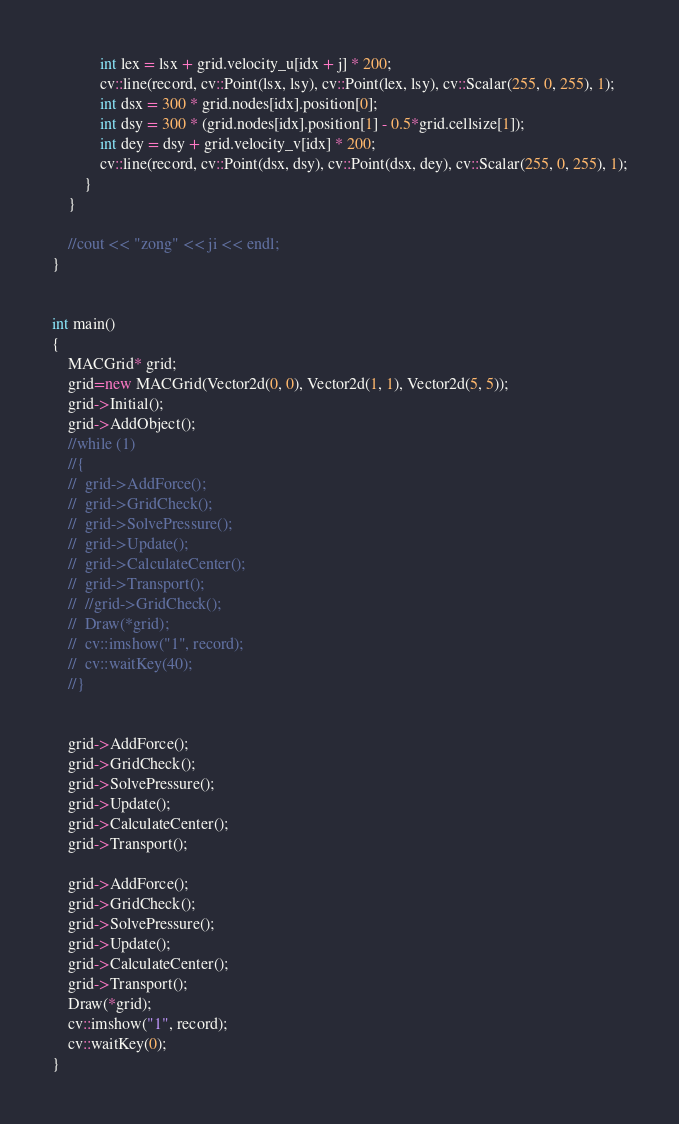Convert code to text. <code><loc_0><loc_0><loc_500><loc_500><_C++_>			int lex = lsx + grid.velocity_u[idx + j] * 200;
			cv::line(record, cv::Point(lsx, lsy), cv::Point(lex, lsy), cv::Scalar(255, 0, 255), 1);
			int dsx = 300 * grid.nodes[idx].position[0];
			int dsy = 300 * (grid.nodes[idx].position[1] - 0.5*grid.cellsize[1]);
			int dey = dsy + grid.velocity_v[idx] * 200;
			cv::line(record, cv::Point(dsx, dsy), cv::Point(dsx, dey), cv::Scalar(255, 0, 255), 1);
		}
	}

	//cout << "zong" << ji << endl;
}


int main()
{
	MACGrid* grid;
	grid=new MACGrid(Vector2d(0, 0), Vector2d(1, 1), Vector2d(5, 5));
	grid->Initial();
	grid->AddObject();
	//while (1)
	//{
	//	grid->AddForce();
	//	grid->GridCheck();
	//	grid->SolvePressure();
	//	grid->Update();
	//	grid->CalculateCenter();
	//	grid->Transport();
	//	//grid->GridCheck();
	//	Draw(*grid);
	//	cv::imshow("1", record);
	//	cv::waitKey(40);
	//}
	

	grid->AddForce();
	grid->GridCheck();
	grid->SolvePressure();
	grid->Update();
	grid->CalculateCenter();
	grid->Transport();

	grid->AddForce();
	grid->GridCheck();
	grid->SolvePressure();
	grid->Update();
	grid->CalculateCenter();
	grid->Transport();
	Draw(*grid);
	cv::imshow("1", record);
	cv::waitKey(0);
}

</code> 